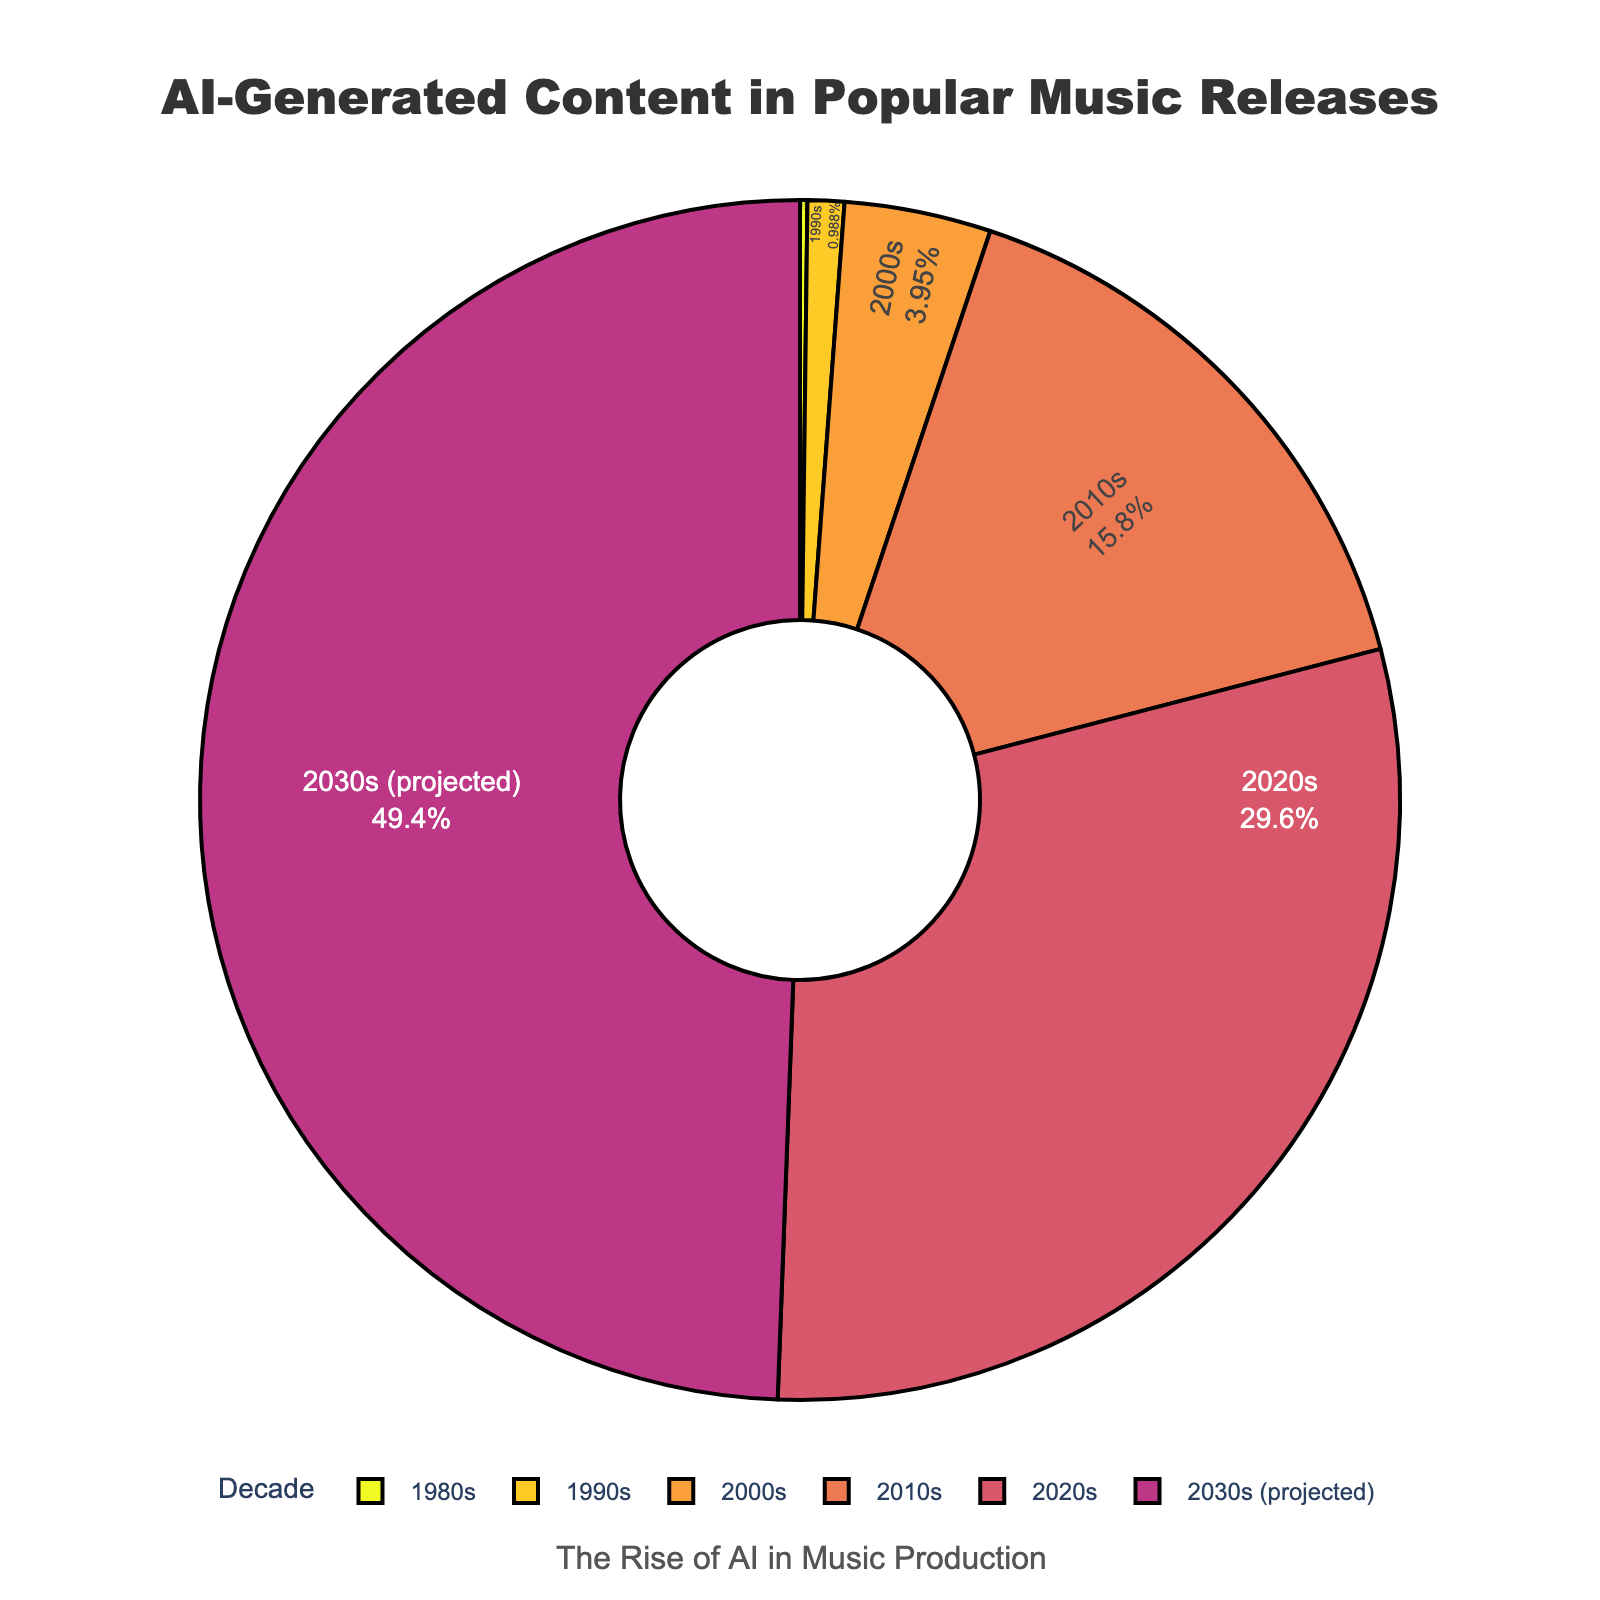Which decade has the highest percentage of AI-generated content? Looking at the chart, the 2030s (projected) section is the largest, indicating it has the highest percentage of AI-generated content.
Answer: 2030s (projected) By how much did the percentage of AI-generated content increase from the 2000s to the 2010s? The percentage in the 2010s is 8%, and in the 2000s, it is 2%, so the increase is 8% - 2% = 6%.
Answer: 6% What is the total percentage of AI-generated content predicted for the future decades (2020s and 2030s)? The percentages for the 2020s and 2030s are 15% and 25%, respectively. Adding these gives 15% + 25% = 40%.
Answer: 40% How does the percentage of AI-generated content in the 1990s compare with that in the 1980s? The percentage in the 1990s is 0.5%, and in the 1980s, it is 0.1%. Therefore, the 1990s have a higher percentage than the 1980s.
Answer: 1990s > 1980s What percentage of AI-generated content is there in the 2010s compared to the 2000s? The percentage in the 2010s is 8%, and in the 2000s, it is 2%. Thus, the percentage in the 2010s is 4 times greater than in the 2000s.
Answer: 4 times greater What is the difference in the percentage of AI-generated content between the 2020s and the 1980s? The percentage in the 2020s is 15%, and in the 1980s, it is 0.1%. So, the difference is 15% - 0.1% = 14.9%.
Answer: 14.9% What is the average percentage of AI-generated content for the decades listed (1980s to 2030s)? Summing the percentages: 0.1% + 0.5% + 2% + 8% + 15% + 25% = 50.6%. There are 6 decades, so the average is 50.6% / 6 = 8.43%.
Answer: 8.43% What colors are used to represent the different decades on the pie chart? The chart uses a sequential color scale ranging from cool to warm tones; specific colors for each decade can be identified when viewing the pie chart.
Answer: Sequential cool to warm tones Between which two consecutive decades is the largest increase in the percentage of AI-generated content observed? From the 2020s to the 2030s, the increase is from 15% to 25%, which is 10%. This is the largest increase compared to other consecutive decades.
Answer: 2020s to 2030s What fraction of the total AI-generated content does the 2010s represent? Summing all percentages (0.1%, 0.5%, 2%, 8%, 15%, 25%) gives 50.6%. The percentage for the 2010s is 8%. So, the fraction is 8% / 50.6% = 0.158.
Answer: 0.158 